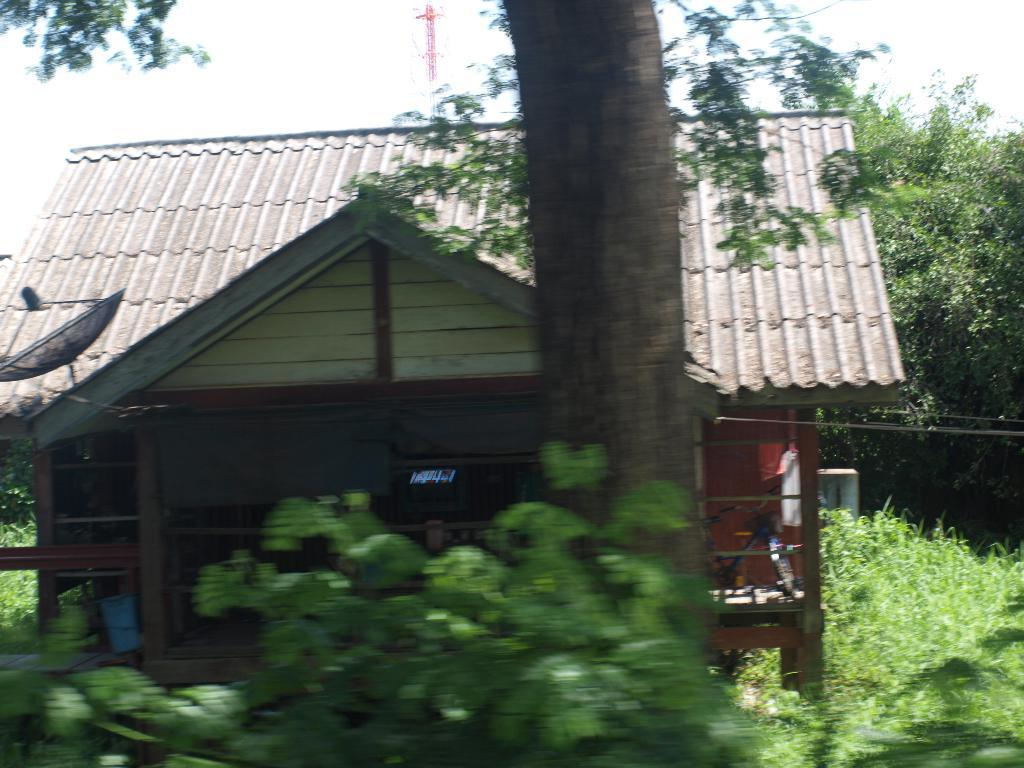What type of structure is visible in the image? There is a house in the image. What can be found inside the house? There is a bicycle inside the house. What is located in front of the house? There is a tree trunk and plants in front of the house. What is visible behind the house? There are trees and a tower behind the house, as well as the sky. How many beans are on the bicycle in the image? There are no beans present in the image, and the bicycle is inside the house, not outside where beans might be found. 